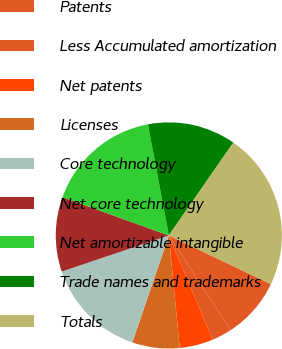Convert chart. <chart><loc_0><loc_0><loc_500><loc_500><pie_chart><fcel>Patents<fcel>Less Accumulated amortization<fcel>Net patents<fcel>Licenses<fcel>Core technology<fcel>Net core technology<fcel>Net amortizable intangible<fcel>Trade names and trademarks<fcel>Totals<nl><fcel>8.72%<fcel>2.86%<fcel>4.81%<fcel>6.77%<fcel>14.59%<fcel>10.68%<fcel>16.54%<fcel>12.63%<fcel>22.41%<nl></chart> 